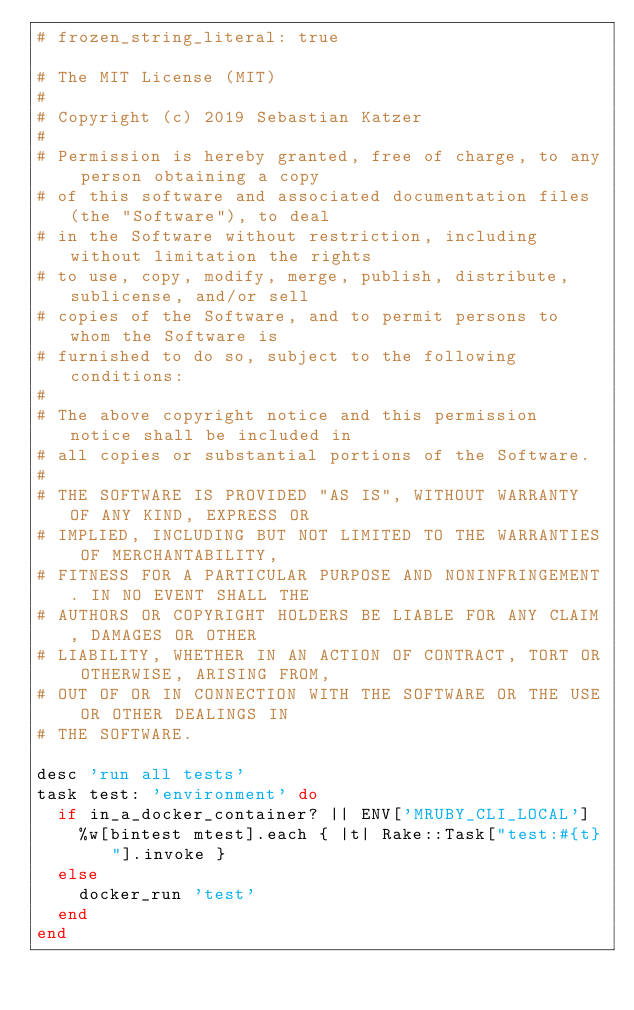<code> <loc_0><loc_0><loc_500><loc_500><_Ruby_># frozen_string_literal: true

# The MIT License (MIT)
#
# Copyright (c) 2019 Sebastian Katzer
#
# Permission is hereby granted, free of charge, to any person obtaining a copy
# of this software and associated documentation files (the "Software"), to deal
# in the Software without restriction, including without limitation the rights
# to use, copy, modify, merge, publish, distribute, sublicense, and/or sell
# copies of the Software, and to permit persons to whom the Software is
# furnished to do so, subject to the following conditions:
#
# The above copyright notice and this permission notice shall be included in
# all copies or substantial portions of the Software.
#
# THE SOFTWARE IS PROVIDED "AS IS", WITHOUT WARRANTY OF ANY KIND, EXPRESS OR
# IMPLIED, INCLUDING BUT NOT LIMITED TO THE WARRANTIES OF MERCHANTABILITY,
# FITNESS FOR A PARTICULAR PURPOSE AND NONINFRINGEMENT. IN NO EVENT SHALL THE
# AUTHORS OR COPYRIGHT HOLDERS BE LIABLE FOR ANY CLAIM, DAMAGES OR OTHER
# LIABILITY, WHETHER IN AN ACTION OF CONTRACT, TORT OR OTHERWISE, ARISING FROM,
# OUT OF OR IN CONNECTION WITH THE SOFTWARE OR THE USE OR OTHER DEALINGS IN
# THE SOFTWARE.

desc 'run all tests'
task test: 'environment' do
  if in_a_docker_container? || ENV['MRUBY_CLI_LOCAL']
    %w[bintest mtest].each { |t| Rake::Task["test:#{t}"].invoke }
  else
    docker_run 'test'
  end
end
</code> 